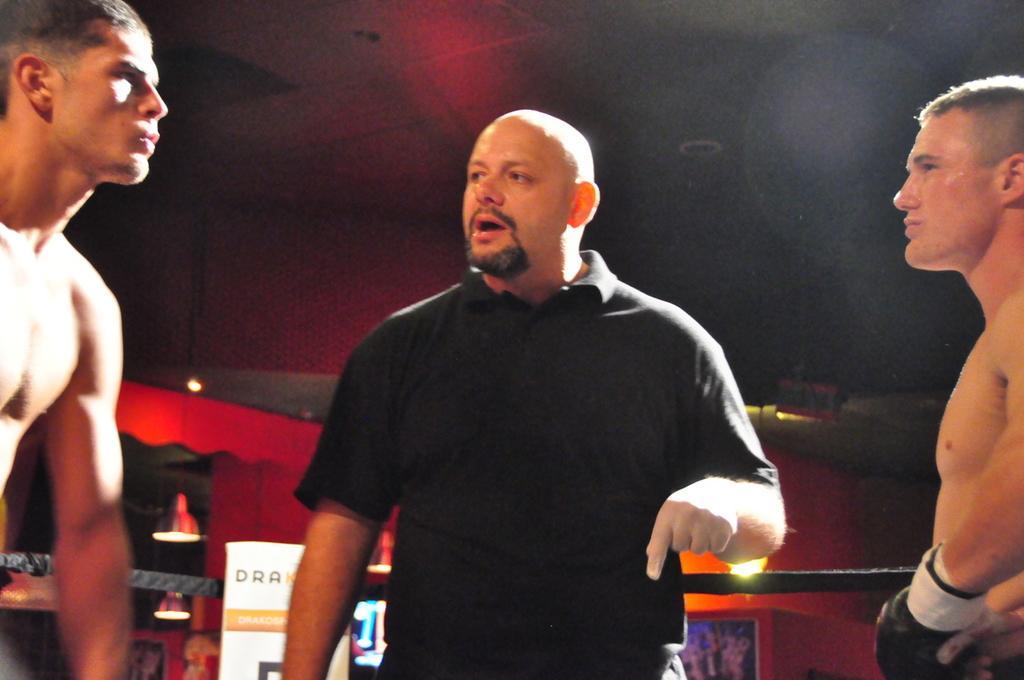Please provide a concise description of this image. In the picture I can see three men in the wrestling ring. There is a man in the middle of the picture wearing a black color T-shirt and looks like he is giving instructions. I can see two wrestling players, One is on the left side and the other one is on the right side. I can see the lamps on the roof. 